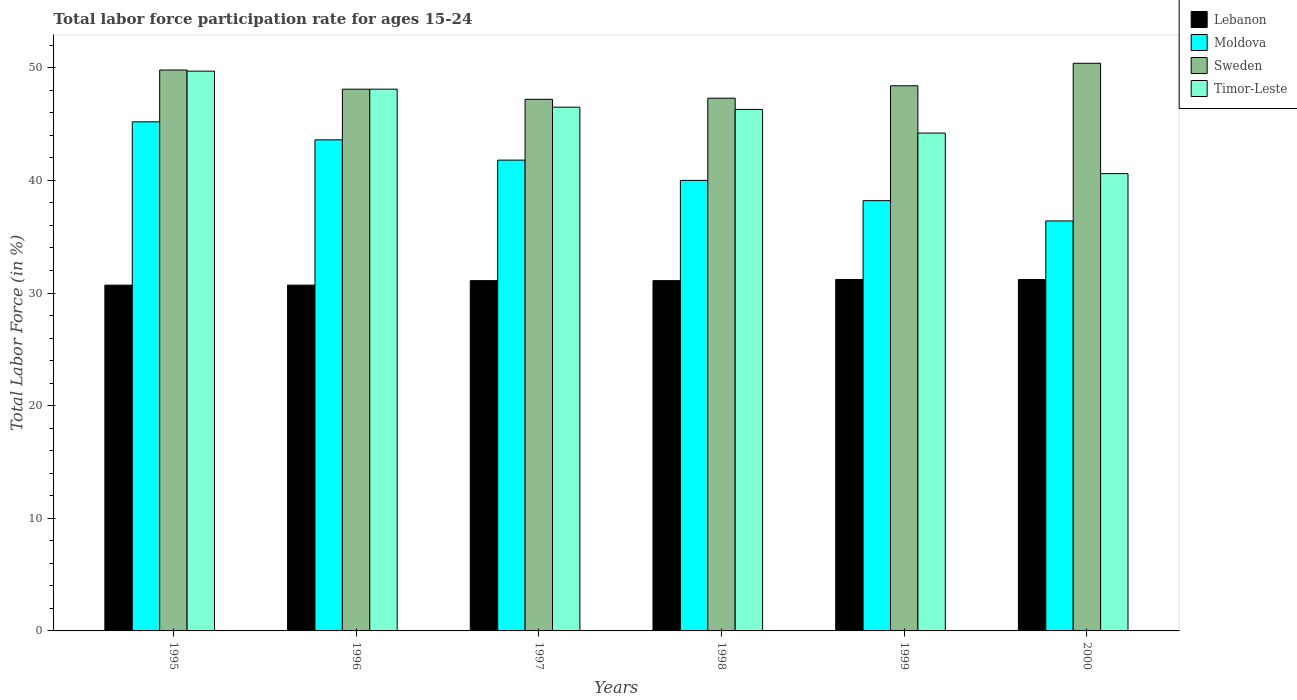Are the number of bars per tick equal to the number of legend labels?
Give a very brief answer. Yes. Are the number of bars on each tick of the X-axis equal?
Your response must be concise. Yes. How many bars are there on the 2nd tick from the left?
Make the answer very short. 4. How many bars are there on the 6th tick from the right?
Give a very brief answer. 4. What is the labor force participation rate in Lebanon in 1995?
Your answer should be very brief. 30.7. Across all years, what is the maximum labor force participation rate in Lebanon?
Ensure brevity in your answer.  31.2. Across all years, what is the minimum labor force participation rate in Moldova?
Offer a very short reply. 36.4. In which year was the labor force participation rate in Sweden maximum?
Offer a very short reply. 2000. In which year was the labor force participation rate in Moldova minimum?
Ensure brevity in your answer.  2000. What is the total labor force participation rate in Moldova in the graph?
Your answer should be very brief. 245.2. What is the difference between the labor force participation rate in Timor-Leste in 1995 and that in 2000?
Give a very brief answer. 9.1. What is the difference between the labor force participation rate in Lebanon in 1996 and the labor force participation rate in Moldova in 1995?
Make the answer very short. -14.5. What is the average labor force participation rate in Timor-Leste per year?
Your answer should be compact. 45.9. In the year 1998, what is the difference between the labor force participation rate in Lebanon and labor force participation rate in Sweden?
Offer a terse response. -16.2. In how many years, is the labor force participation rate in Moldova greater than 22 %?
Give a very brief answer. 6. What is the ratio of the labor force participation rate in Timor-Leste in 1996 to that in 1999?
Your answer should be very brief. 1.09. Is the labor force participation rate in Moldova in 1995 less than that in 1998?
Your answer should be compact. No. Is the difference between the labor force participation rate in Lebanon in 1995 and 1999 greater than the difference between the labor force participation rate in Sweden in 1995 and 1999?
Provide a succinct answer. No. What is the difference between the highest and the lowest labor force participation rate in Moldova?
Keep it short and to the point. 8.8. In how many years, is the labor force participation rate in Lebanon greater than the average labor force participation rate in Lebanon taken over all years?
Keep it short and to the point. 4. Is it the case that in every year, the sum of the labor force participation rate in Sweden and labor force participation rate in Timor-Leste is greater than the sum of labor force participation rate in Lebanon and labor force participation rate in Moldova?
Offer a very short reply. No. What does the 1st bar from the left in 1998 represents?
Offer a very short reply. Lebanon. What does the 2nd bar from the right in 1999 represents?
Your answer should be compact. Sweden. Are all the bars in the graph horizontal?
Your answer should be compact. No. How many years are there in the graph?
Provide a succinct answer. 6. Does the graph contain any zero values?
Ensure brevity in your answer.  No. Does the graph contain grids?
Your answer should be compact. No. What is the title of the graph?
Offer a terse response. Total labor force participation rate for ages 15-24. Does "Kuwait" appear as one of the legend labels in the graph?
Your answer should be very brief. No. What is the label or title of the Y-axis?
Your response must be concise. Total Labor Force (in %). What is the Total Labor Force (in %) of Lebanon in 1995?
Offer a very short reply. 30.7. What is the Total Labor Force (in %) in Moldova in 1995?
Your answer should be very brief. 45.2. What is the Total Labor Force (in %) of Sweden in 1995?
Offer a terse response. 49.8. What is the Total Labor Force (in %) of Timor-Leste in 1995?
Keep it short and to the point. 49.7. What is the Total Labor Force (in %) of Lebanon in 1996?
Your answer should be compact. 30.7. What is the Total Labor Force (in %) of Moldova in 1996?
Keep it short and to the point. 43.6. What is the Total Labor Force (in %) of Sweden in 1996?
Make the answer very short. 48.1. What is the Total Labor Force (in %) of Timor-Leste in 1996?
Provide a short and direct response. 48.1. What is the Total Labor Force (in %) in Lebanon in 1997?
Provide a short and direct response. 31.1. What is the Total Labor Force (in %) of Moldova in 1997?
Make the answer very short. 41.8. What is the Total Labor Force (in %) of Sweden in 1997?
Offer a terse response. 47.2. What is the Total Labor Force (in %) of Timor-Leste in 1997?
Your answer should be compact. 46.5. What is the Total Labor Force (in %) in Lebanon in 1998?
Your answer should be very brief. 31.1. What is the Total Labor Force (in %) of Sweden in 1998?
Provide a succinct answer. 47.3. What is the Total Labor Force (in %) of Timor-Leste in 1998?
Your answer should be very brief. 46.3. What is the Total Labor Force (in %) in Lebanon in 1999?
Offer a terse response. 31.2. What is the Total Labor Force (in %) of Moldova in 1999?
Ensure brevity in your answer.  38.2. What is the Total Labor Force (in %) in Sweden in 1999?
Your answer should be very brief. 48.4. What is the Total Labor Force (in %) of Timor-Leste in 1999?
Your answer should be very brief. 44.2. What is the Total Labor Force (in %) of Lebanon in 2000?
Make the answer very short. 31.2. What is the Total Labor Force (in %) in Moldova in 2000?
Provide a succinct answer. 36.4. What is the Total Labor Force (in %) of Sweden in 2000?
Offer a very short reply. 50.4. What is the Total Labor Force (in %) in Timor-Leste in 2000?
Give a very brief answer. 40.6. Across all years, what is the maximum Total Labor Force (in %) in Lebanon?
Your answer should be compact. 31.2. Across all years, what is the maximum Total Labor Force (in %) in Moldova?
Offer a very short reply. 45.2. Across all years, what is the maximum Total Labor Force (in %) of Sweden?
Provide a short and direct response. 50.4. Across all years, what is the maximum Total Labor Force (in %) of Timor-Leste?
Provide a short and direct response. 49.7. Across all years, what is the minimum Total Labor Force (in %) of Lebanon?
Provide a succinct answer. 30.7. Across all years, what is the minimum Total Labor Force (in %) in Moldova?
Make the answer very short. 36.4. Across all years, what is the minimum Total Labor Force (in %) of Sweden?
Keep it short and to the point. 47.2. Across all years, what is the minimum Total Labor Force (in %) in Timor-Leste?
Keep it short and to the point. 40.6. What is the total Total Labor Force (in %) in Lebanon in the graph?
Give a very brief answer. 186. What is the total Total Labor Force (in %) of Moldova in the graph?
Your answer should be compact. 245.2. What is the total Total Labor Force (in %) of Sweden in the graph?
Ensure brevity in your answer.  291.2. What is the total Total Labor Force (in %) in Timor-Leste in the graph?
Keep it short and to the point. 275.4. What is the difference between the Total Labor Force (in %) in Moldova in 1995 and that in 1996?
Make the answer very short. 1.6. What is the difference between the Total Labor Force (in %) of Sweden in 1995 and that in 1996?
Give a very brief answer. 1.7. What is the difference between the Total Labor Force (in %) of Moldova in 1995 and that in 1997?
Give a very brief answer. 3.4. What is the difference between the Total Labor Force (in %) in Timor-Leste in 1995 and that in 1997?
Your answer should be very brief. 3.2. What is the difference between the Total Labor Force (in %) of Lebanon in 1995 and that in 1998?
Provide a succinct answer. -0.4. What is the difference between the Total Labor Force (in %) in Sweden in 1995 and that in 1998?
Keep it short and to the point. 2.5. What is the difference between the Total Labor Force (in %) in Sweden in 1995 and that in 1999?
Your answer should be compact. 1.4. What is the difference between the Total Labor Force (in %) in Timor-Leste in 1995 and that in 1999?
Give a very brief answer. 5.5. What is the difference between the Total Labor Force (in %) in Lebanon in 1995 and that in 2000?
Keep it short and to the point. -0.5. What is the difference between the Total Labor Force (in %) in Sweden in 1995 and that in 2000?
Provide a succinct answer. -0.6. What is the difference between the Total Labor Force (in %) of Moldova in 1996 and that in 1997?
Keep it short and to the point. 1.8. What is the difference between the Total Labor Force (in %) of Lebanon in 1996 and that in 1998?
Give a very brief answer. -0.4. What is the difference between the Total Labor Force (in %) in Moldova in 1996 and that in 1998?
Give a very brief answer. 3.6. What is the difference between the Total Labor Force (in %) in Sweden in 1996 and that in 1998?
Your answer should be compact. 0.8. What is the difference between the Total Labor Force (in %) of Timor-Leste in 1996 and that in 1998?
Ensure brevity in your answer.  1.8. What is the difference between the Total Labor Force (in %) of Lebanon in 1996 and that in 1999?
Ensure brevity in your answer.  -0.5. What is the difference between the Total Labor Force (in %) of Sweden in 1996 and that in 1999?
Make the answer very short. -0.3. What is the difference between the Total Labor Force (in %) of Timor-Leste in 1996 and that in 1999?
Make the answer very short. 3.9. What is the difference between the Total Labor Force (in %) of Moldova in 1996 and that in 2000?
Make the answer very short. 7.2. What is the difference between the Total Labor Force (in %) in Moldova in 1997 and that in 1998?
Give a very brief answer. 1.8. What is the difference between the Total Labor Force (in %) of Sweden in 1997 and that in 1998?
Your answer should be very brief. -0.1. What is the difference between the Total Labor Force (in %) in Lebanon in 1997 and that in 2000?
Your response must be concise. -0.1. What is the difference between the Total Labor Force (in %) of Moldova in 1997 and that in 2000?
Offer a very short reply. 5.4. What is the difference between the Total Labor Force (in %) in Sweden in 1997 and that in 2000?
Make the answer very short. -3.2. What is the difference between the Total Labor Force (in %) in Timor-Leste in 1997 and that in 2000?
Your response must be concise. 5.9. What is the difference between the Total Labor Force (in %) of Timor-Leste in 1998 and that in 1999?
Your response must be concise. 2.1. What is the difference between the Total Labor Force (in %) of Lebanon in 1998 and that in 2000?
Offer a very short reply. -0.1. What is the difference between the Total Labor Force (in %) of Sweden in 1998 and that in 2000?
Keep it short and to the point. -3.1. What is the difference between the Total Labor Force (in %) in Timor-Leste in 1998 and that in 2000?
Give a very brief answer. 5.7. What is the difference between the Total Labor Force (in %) of Lebanon in 1999 and that in 2000?
Offer a terse response. 0. What is the difference between the Total Labor Force (in %) of Moldova in 1999 and that in 2000?
Your answer should be compact. 1.8. What is the difference between the Total Labor Force (in %) of Sweden in 1999 and that in 2000?
Ensure brevity in your answer.  -2. What is the difference between the Total Labor Force (in %) in Lebanon in 1995 and the Total Labor Force (in %) in Moldova in 1996?
Provide a succinct answer. -12.9. What is the difference between the Total Labor Force (in %) in Lebanon in 1995 and the Total Labor Force (in %) in Sweden in 1996?
Provide a succinct answer. -17.4. What is the difference between the Total Labor Force (in %) of Lebanon in 1995 and the Total Labor Force (in %) of Timor-Leste in 1996?
Provide a short and direct response. -17.4. What is the difference between the Total Labor Force (in %) of Lebanon in 1995 and the Total Labor Force (in %) of Moldova in 1997?
Offer a very short reply. -11.1. What is the difference between the Total Labor Force (in %) of Lebanon in 1995 and the Total Labor Force (in %) of Sweden in 1997?
Keep it short and to the point. -16.5. What is the difference between the Total Labor Force (in %) of Lebanon in 1995 and the Total Labor Force (in %) of Timor-Leste in 1997?
Provide a short and direct response. -15.8. What is the difference between the Total Labor Force (in %) of Moldova in 1995 and the Total Labor Force (in %) of Sweden in 1997?
Provide a succinct answer. -2. What is the difference between the Total Labor Force (in %) in Sweden in 1995 and the Total Labor Force (in %) in Timor-Leste in 1997?
Your answer should be very brief. 3.3. What is the difference between the Total Labor Force (in %) in Lebanon in 1995 and the Total Labor Force (in %) in Moldova in 1998?
Provide a succinct answer. -9.3. What is the difference between the Total Labor Force (in %) in Lebanon in 1995 and the Total Labor Force (in %) in Sweden in 1998?
Make the answer very short. -16.6. What is the difference between the Total Labor Force (in %) of Lebanon in 1995 and the Total Labor Force (in %) of Timor-Leste in 1998?
Keep it short and to the point. -15.6. What is the difference between the Total Labor Force (in %) of Lebanon in 1995 and the Total Labor Force (in %) of Sweden in 1999?
Make the answer very short. -17.7. What is the difference between the Total Labor Force (in %) in Moldova in 1995 and the Total Labor Force (in %) in Sweden in 1999?
Your response must be concise. -3.2. What is the difference between the Total Labor Force (in %) in Lebanon in 1995 and the Total Labor Force (in %) in Moldova in 2000?
Your response must be concise. -5.7. What is the difference between the Total Labor Force (in %) in Lebanon in 1995 and the Total Labor Force (in %) in Sweden in 2000?
Make the answer very short. -19.7. What is the difference between the Total Labor Force (in %) in Lebanon in 1995 and the Total Labor Force (in %) in Timor-Leste in 2000?
Offer a terse response. -9.9. What is the difference between the Total Labor Force (in %) of Moldova in 1995 and the Total Labor Force (in %) of Sweden in 2000?
Your answer should be very brief. -5.2. What is the difference between the Total Labor Force (in %) of Moldova in 1995 and the Total Labor Force (in %) of Timor-Leste in 2000?
Your response must be concise. 4.6. What is the difference between the Total Labor Force (in %) of Lebanon in 1996 and the Total Labor Force (in %) of Moldova in 1997?
Provide a short and direct response. -11.1. What is the difference between the Total Labor Force (in %) of Lebanon in 1996 and the Total Labor Force (in %) of Sweden in 1997?
Provide a succinct answer. -16.5. What is the difference between the Total Labor Force (in %) of Lebanon in 1996 and the Total Labor Force (in %) of Timor-Leste in 1997?
Keep it short and to the point. -15.8. What is the difference between the Total Labor Force (in %) in Moldova in 1996 and the Total Labor Force (in %) in Sweden in 1997?
Give a very brief answer. -3.6. What is the difference between the Total Labor Force (in %) in Lebanon in 1996 and the Total Labor Force (in %) in Sweden in 1998?
Keep it short and to the point. -16.6. What is the difference between the Total Labor Force (in %) of Lebanon in 1996 and the Total Labor Force (in %) of Timor-Leste in 1998?
Offer a terse response. -15.6. What is the difference between the Total Labor Force (in %) in Moldova in 1996 and the Total Labor Force (in %) in Timor-Leste in 1998?
Offer a very short reply. -2.7. What is the difference between the Total Labor Force (in %) in Sweden in 1996 and the Total Labor Force (in %) in Timor-Leste in 1998?
Provide a succinct answer. 1.8. What is the difference between the Total Labor Force (in %) of Lebanon in 1996 and the Total Labor Force (in %) of Sweden in 1999?
Make the answer very short. -17.7. What is the difference between the Total Labor Force (in %) in Moldova in 1996 and the Total Labor Force (in %) in Sweden in 1999?
Offer a very short reply. -4.8. What is the difference between the Total Labor Force (in %) in Moldova in 1996 and the Total Labor Force (in %) in Timor-Leste in 1999?
Make the answer very short. -0.6. What is the difference between the Total Labor Force (in %) of Sweden in 1996 and the Total Labor Force (in %) of Timor-Leste in 1999?
Offer a terse response. 3.9. What is the difference between the Total Labor Force (in %) in Lebanon in 1996 and the Total Labor Force (in %) in Moldova in 2000?
Make the answer very short. -5.7. What is the difference between the Total Labor Force (in %) of Lebanon in 1996 and the Total Labor Force (in %) of Sweden in 2000?
Your answer should be very brief. -19.7. What is the difference between the Total Labor Force (in %) of Lebanon in 1996 and the Total Labor Force (in %) of Timor-Leste in 2000?
Your answer should be very brief. -9.9. What is the difference between the Total Labor Force (in %) in Moldova in 1996 and the Total Labor Force (in %) in Timor-Leste in 2000?
Make the answer very short. 3. What is the difference between the Total Labor Force (in %) of Lebanon in 1997 and the Total Labor Force (in %) of Moldova in 1998?
Provide a succinct answer. -8.9. What is the difference between the Total Labor Force (in %) of Lebanon in 1997 and the Total Labor Force (in %) of Sweden in 1998?
Offer a very short reply. -16.2. What is the difference between the Total Labor Force (in %) in Lebanon in 1997 and the Total Labor Force (in %) in Timor-Leste in 1998?
Your answer should be very brief. -15.2. What is the difference between the Total Labor Force (in %) in Moldova in 1997 and the Total Labor Force (in %) in Timor-Leste in 1998?
Give a very brief answer. -4.5. What is the difference between the Total Labor Force (in %) in Sweden in 1997 and the Total Labor Force (in %) in Timor-Leste in 1998?
Keep it short and to the point. 0.9. What is the difference between the Total Labor Force (in %) in Lebanon in 1997 and the Total Labor Force (in %) in Moldova in 1999?
Provide a succinct answer. -7.1. What is the difference between the Total Labor Force (in %) in Lebanon in 1997 and the Total Labor Force (in %) in Sweden in 1999?
Give a very brief answer. -17.3. What is the difference between the Total Labor Force (in %) of Moldova in 1997 and the Total Labor Force (in %) of Sweden in 1999?
Offer a very short reply. -6.6. What is the difference between the Total Labor Force (in %) of Sweden in 1997 and the Total Labor Force (in %) of Timor-Leste in 1999?
Make the answer very short. 3. What is the difference between the Total Labor Force (in %) in Lebanon in 1997 and the Total Labor Force (in %) in Sweden in 2000?
Give a very brief answer. -19.3. What is the difference between the Total Labor Force (in %) of Moldova in 1997 and the Total Labor Force (in %) of Sweden in 2000?
Ensure brevity in your answer.  -8.6. What is the difference between the Total Labor Force (in %) of Sweden in 1997 and the Total Labor Force (in %) of Timor-Leste in 2000?
Offer a very short reply. 6.6. What is the difference between the Total Labor Force (in %) in Lebanon in 1998 and the Total Labor Force (in %) in Sweden in 1999?
Make the answer very short. -17.3. What is the difference between the Total Labor Force (in %) in Moldova in 1998 and the Total Labor Force (in %) in Timor-Leste in 1999?
Ensure brevity in your answer.  -4.2. What is the difference between the Total Labor Force (in %) in Lebanon in 1998 and the Total Labor Force (in %) in Sweden in 2000?
Make the answer very short. -19.3. What is the difference between the Total Labor Force (in %) in Lebanon in 1998 and the Total Labor Force (in %) in Timor-Leste in 2000?
Provide a succinct answer. -9.5. What is the difference between the Total Labor Force (in %) of Moldova in 1998 and the Total Labor Force (in %) of Sweden in 2000?
Offer a terse response. -10.4. What is the difference between the Total Labor Force (in %) in Sweden in 1998 and the Total Labor Force (in %) in Timor-Leste in 2000?
Keep it short and to the point. 6.7. What is the difference between the Total Labor Force (in %) in Lebanon in 1999 and the Total Labor Force (in %) in Sweden in 2000?
Offer a very short reply. -19.2. What is the average Total Labor Force (in %) in Lebanon per year?
Provide a short and direct response. 31. What is the average Total Labor Force (in %) of Moldova per year?
Your response must be concise. 40.87. What is the average Total Labor Force (in %) of Sweden per year?
Give a very brief answer. 48.53. What is the average Total Labor Force (in %) in Timor-Leste per year?
Your answer should be very brief. 45.9. In the year 1995, what is the difference between the Total Labor Force (in %) in Lebanon and Total Labor Force (in %) in Moldova?
Give a very brief answer. -14.5. In the year 1995, what is the difference between the Total Labor Force (in %) in Lebanon and Total Labor Force (in %) in Sweden?
Offer a terse response. -19.1. In the year 1995, what is the difference between the Total Labor Force (in %) of Lebanon and Total Labor Force (in %) of Timor-Leste?
Your response must be concise. -19. In the year 1995, what is the difference between the Total Labor Force (in %) of Moldova and Total Labor Force (in %) of Timor-Leste?
Offer a terse response. -4.5. In the year 1996, what is the difference between the Total Labor Force (in %) in Lebanon and Total Labor Force (in %) in Sweden?
Give a very brief answer. -17.4. In the year 1996, what is the difference between the Total Labor Force (in %) in Lebanon and Total Labor Force (in %) in Timor-Leste?
Your answer should be compact. -17.4. In the year 1996, what is the difference between the Total Labor Force (in %) in Moldova and Total Labor Force (in %) in Sweden?
Your answer should be compact. -4.5. In the year 1996, what is the difference between the Total Labor Force (in %) of Moldova and Total Labor Force (in %) of Timor-Leste?
Keep it short and to the point. -4.5. In the year 1997, what is the difference between the Total Labor Force (in %) in Lebanon and Total Labor Force (in %) in Sweden?
Give a very brief answer. -16.1. In the year 1997, what is the difference between the Total Labor Force (in %) of Lebanon and Total Labor Force (in %) of Timor-Leste?
Offer a very short reply. -15.4. In the year 1997, what is the difference between the Total Labor Force (in %) in Moldova and Total Labor Force (in %) in Sweden?
Your response must be concise. -5.4. In the year 1998, what is the difference between the Total Labor Force (in %) in Lebanon and Total Labor Force (in %) in Moldova?
Your response must be concise. -8.9. In the year 1998, what is the difference between the Total Labor Force (in %) of Lebanon and Total Labor Force (in %) of Sweden?
Offer a very short reply. -16.2. In the year 1998, what is the difference between the Total Labor Force (in %) of Lebanon and Total Labor Force (in %) of Timor-Leste?
Your answer should be compact. -15.2. In the year 1998, what is the difference between the Total Labor Force (in %) of Moldova and Total Labor Force (in %) of Timor-Leste?
Your response must be concise. -6.3. In the year 1998, what is the difference between the Total Labor Force (in %) of Sweden and Total Labor Force (in %) of Timor-Leste?
Make the answer very short. 1. In the year 1999, what is the difference between the Total Labor Force (in %) of Lebanon and Total Labor Force (in %) of Sweden?
Provide a short and direct response. -17.2. In the year 1999, what is the difference between the Total Labor Force (in %) in Moldova and Total Labor Force (in %) in Timor-Leste?
Keep it short and to the point. -6. In the year 1999, what is the difference between the Total Labor Force (in %) in Sweden and Total Labor Force (in %) in Timor-Leste?
Your answer should be compact. 4.2. In the year 2000, what is the difference between the Total Labor Force (in %) in Lebanon and Total Labor Force (in %) in Sweden?
Provide a short and direct response. -19.2. In the year 2000, what is the difference between the Total Labor Force (in %) of Lebanon and Total Labor Force (in %) of Timor-Leste?
Your response must be concise. -9.4. In the year 2000, what is the difference between the Total Labor Force (in %) in Moldova and Total Labor Force (in %) in Timor-Leste?
Keep it short and to the point. -4.2. In the year 2000, what is the difference between the Total Labor Force (in %) of Sweden and Total Labor Force (in %) of Timor-Leste?
Provide a short and direct response. 9.8. What is the ratio of the Total Labor Force (in %) of Lebanon in 1995 to that in 1996?
Provide a succinct answer. 1. What is the ratio of the Total Labor Force (in %) of Moldova in 1995 to that in 1996?
Ensure brevity in your answer.  1.04. What is the ratio of the Total Labor Force (in %) in Sweden in 1995 to that in 1996?
Your answer should be very brief. 1.04. What is the ratio of the Total Labor Force (in %) of Lebanon in 1995 to that in 1997?
Your answer should be compact. 0.99. What is the ratio of the Total Labor Force (in %) of Moldova in 1995 to that in 1997?
Ensure brevity in your answer.  1.08. What is the ratio of the Total Labor Force (in %) in Sweden in 1995 to that in 1997?
Provide a short and direct response. 1.06. What is the ratio of the Total Labor Force (in %) in Timor-Leste in 1995 to that in 1997?
Ensure brevity in your answer.  1.07. What is the ratio of the Total Labor Force (in %) of Lebanon in 1995 to that in 1998?
Provide a succinct answer. 0.99. What is the ratio of the Total Labor Force (in %) of Moldova in 1995 to that in 1998?
Ensure brevity in your answer.  1.13. What is the ratio of the Total Labor Force (in %) in Sweden in 1995 to that in 1998?
Your answer should be very brief. 1.05. What is the ratio of the Total Labor Force (in %) in Timor-Leste in 1995 to that in 1998?
Your answer should be very brief. 1.07. What is the ratio of the Total Labor Force (in %) in Lebanon in 1995 to that in 1999?
Offer a terse response. 0.98. What is the ratio of the Total Labor Force (in %) in Moldova in 1995 to that in 1999?
Offer a very short reply. 1.18. What is the ratio of the Total Labor Force (in %) in Sweden in 1995 to that in 1999?
Provide a succinct answer. 1.03. What is the ratio of the Total Labor Force (in %) in Timor-Leste in 1995 to that in 1999?
Keep it short and to the point. 1.12. What is the ratio of the Total Labor Force (in %) in Moldova in 1995 to that in 2000?
Provide a succinct answer. 1.24. What is the ratio of the Total Labor Force (in %) in Timor-Leste in 1995 to that in 2000?
Keep it short and to the point. 1.22. What is the ratio of the Total Labor Force (in %) of Lebanon in 1996 to that in 1997?
Provide a short and direct response. 0.99. What is the ratio of the Total Labor Force (in %) in Moldova in 1996 to that in 1997?
Your answer should be very brief. 1.04. What is the ratio of the Total Labor Force (in %) in Sweden in 1996 to that in 1997?
Keep it short and to the point. 1.02. What is the ratio of the Total Labor Force (in %) in Timor-Leste in 1996 to that in 1997?
Your response must be concise. 1.03. What is the ratio of the Total Labor Force (in %) of Lebanon in 1996 to that in 1998?
Your answer should be very brief. 0.99. What is the ratio of the Total Labor Force (in %) of Moldova in 1996 to that in 1998?
Provide a succinct answer. 1.09. What is the ratio of the Total Labor Force (in %) in Sweden in 1996 to that in 1998?
Offer a terse response. 1.02. What is the ratio of the Total Labor Force (in %) of Timor-Leste in 1996 to that in 1998?
Ensure brevity in your answer.  1.04. What is the ratio of the Total Labor Force (in %) of Moldova in 1996 to that in 1999?
Offer a terse response. 1.14. What is the ratio of the Total Labor Force (in %) of Sweden in 1996 to that in 1999?
Your answer should be compact. 0.99. What is the ratio of the Total Labor Force (in %) in Timor-Leste in 1996 to that in 1999?
Provide a short and direct response. 1.09. What is the ratio of the Total Labor Force (in %) in Lebanon in 1996 to that in 2000?
Your response must be concise. 0.98. What is the ratio of the Total Labor Force (in %) of Moldova in 1996 to that in 2000?
Ensure brevity in your answer.  1.2. What is the ratio of the Total Labor Force (in %) in Sweden in 1996 to that in 2000?
Your answer should be very brief. 0.95. What is the ratio of the Total Labor Force (in %) of Timor-Leste in 1996 to that in 2000?
Your answer should be very brief. 1.18. What is the ratio of the Total Labor Force (in %) of Lebanon in 1997 to that in 1998?
Your answer should be compact. 1. What is the ratio of the Total Labor Force (in %) in Moldova in 1997 to that in 1998?
Make the answer very short. 1.04. What is the ratio of the Total Labor Force (in %) of Lebanon in 1997 to that in 1999?
Offer a very short reply. 1. What is the ratio of the Total Labor Force (in %) in Moldova in 1997 to that in 1999?
Your response must be concise. 1.09. What is the ratio of the Total Labor Force (in %) of Sweden in 1997 to that in 1999?
Your answer should be compact. 0.98. What is the ratio of the Total Labor Force (in %) in Timor-Leste in 1997 to that in 1999?
Keep it short and to the point. 1.05. What is the ratio of the Total Labor Force (in %) in Moldova in 1997 to that in 2000?
Ensure brevity in your answer.  1.15. What is the ratio of the Total Labor Force (in %) in Sweden in 1997 to that in 2000?
Your answer should be very brief. 0.94. What is the ratio of the Total Labor Force (in %) in Timor-Leste in 1997 to that in 2000?
Offer a very short reply. 1.15. What is the ratio of the Total Labor Force (in %) of Moldova in 1998 to that in 1999?
Keep it short and to the point. 1.05. What is the ratio of the Total Labor Force (in %) of Sweden in 1998 to that in 1999?
Offer a very short reply. 0.98. What is the ratio of the Total Labor Force (in %) of Timor-Leste in 1998 to that in 1999?
Give a very brief answer. 1.05. What is the ratio of the Total Labor Force (in %) in Moldova in 1998 to that in 2000?
Keep it short and to the point. 1.1. What is the ratio of the Total Labor Force (in %) in Sweden in 1998 to that in 2000?
Give a very brief answer. 0.94. What is the ratio of the Total Labor Force (in %) in Timor-Leste in 1998 to that in 2000?
Provide a short and direct response. 1.14. What is the ratio of the Total Labor Force (in %) of Lebanon in 1999 to that in 2000?
Your response must be concise. 1. What is the ratio of the Total Labor Force (in %) of Moldova in 1999 to that in 2000?
Your answer should be compact. 1.05. What is the ratio of the Total Labor Force (in %) of Sweden in 1999 to that in 2000?
Make the answer very short. 0.96. What is the ratio of the Total Labor Force (in %) in Timor-Leste in 1999 to that in 2000?
Offer a very short reply. 1.09. What is the difference between the highest and the second highest Total Labor Force (in %) in Moldova?
Keep it short and to the point. 1.6. What is the difference between the highest and the second highest Total Labor Force (in %) in Sweden?
Provide a succinct answer. 0.6. What is the difference between the highest and the second highest Total Labor Force (in %) of Timor-Leste?
Your response must be concise. 1.6. What is the difference between the highest and the lowest Total Labor Force (in %) of Lebanon?
Offer a terse response. 0.5. What is the difference between the highest and the lowest Total Labor Force (in %) of Moldova?
Ensure brevity in your answer.  8.8. What is the difference between the highest and the lowest Total Labor Force (in %) in Sweden?
Give a very brief answer. 3.2. What is the difference between the highest and the lowest Total Labor Force (in %) in Timor-Leste?
Make the answer very short. 9.1. 